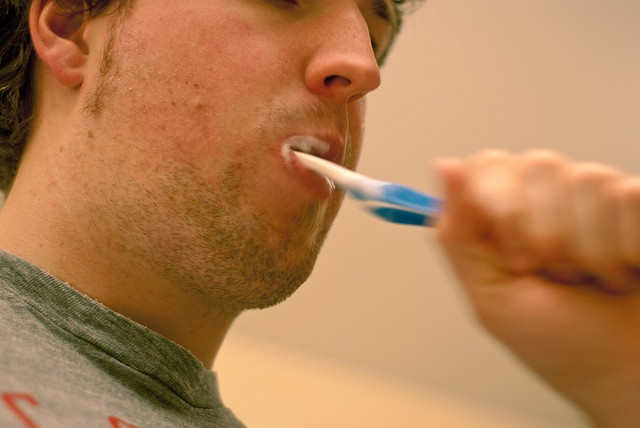Describe the objects in this image and their specific colors. I can see people in black, brown, tan, olive, and salmon tones and toothbrush in black, darkgray, gray, ivory, and tan tones in this image. 